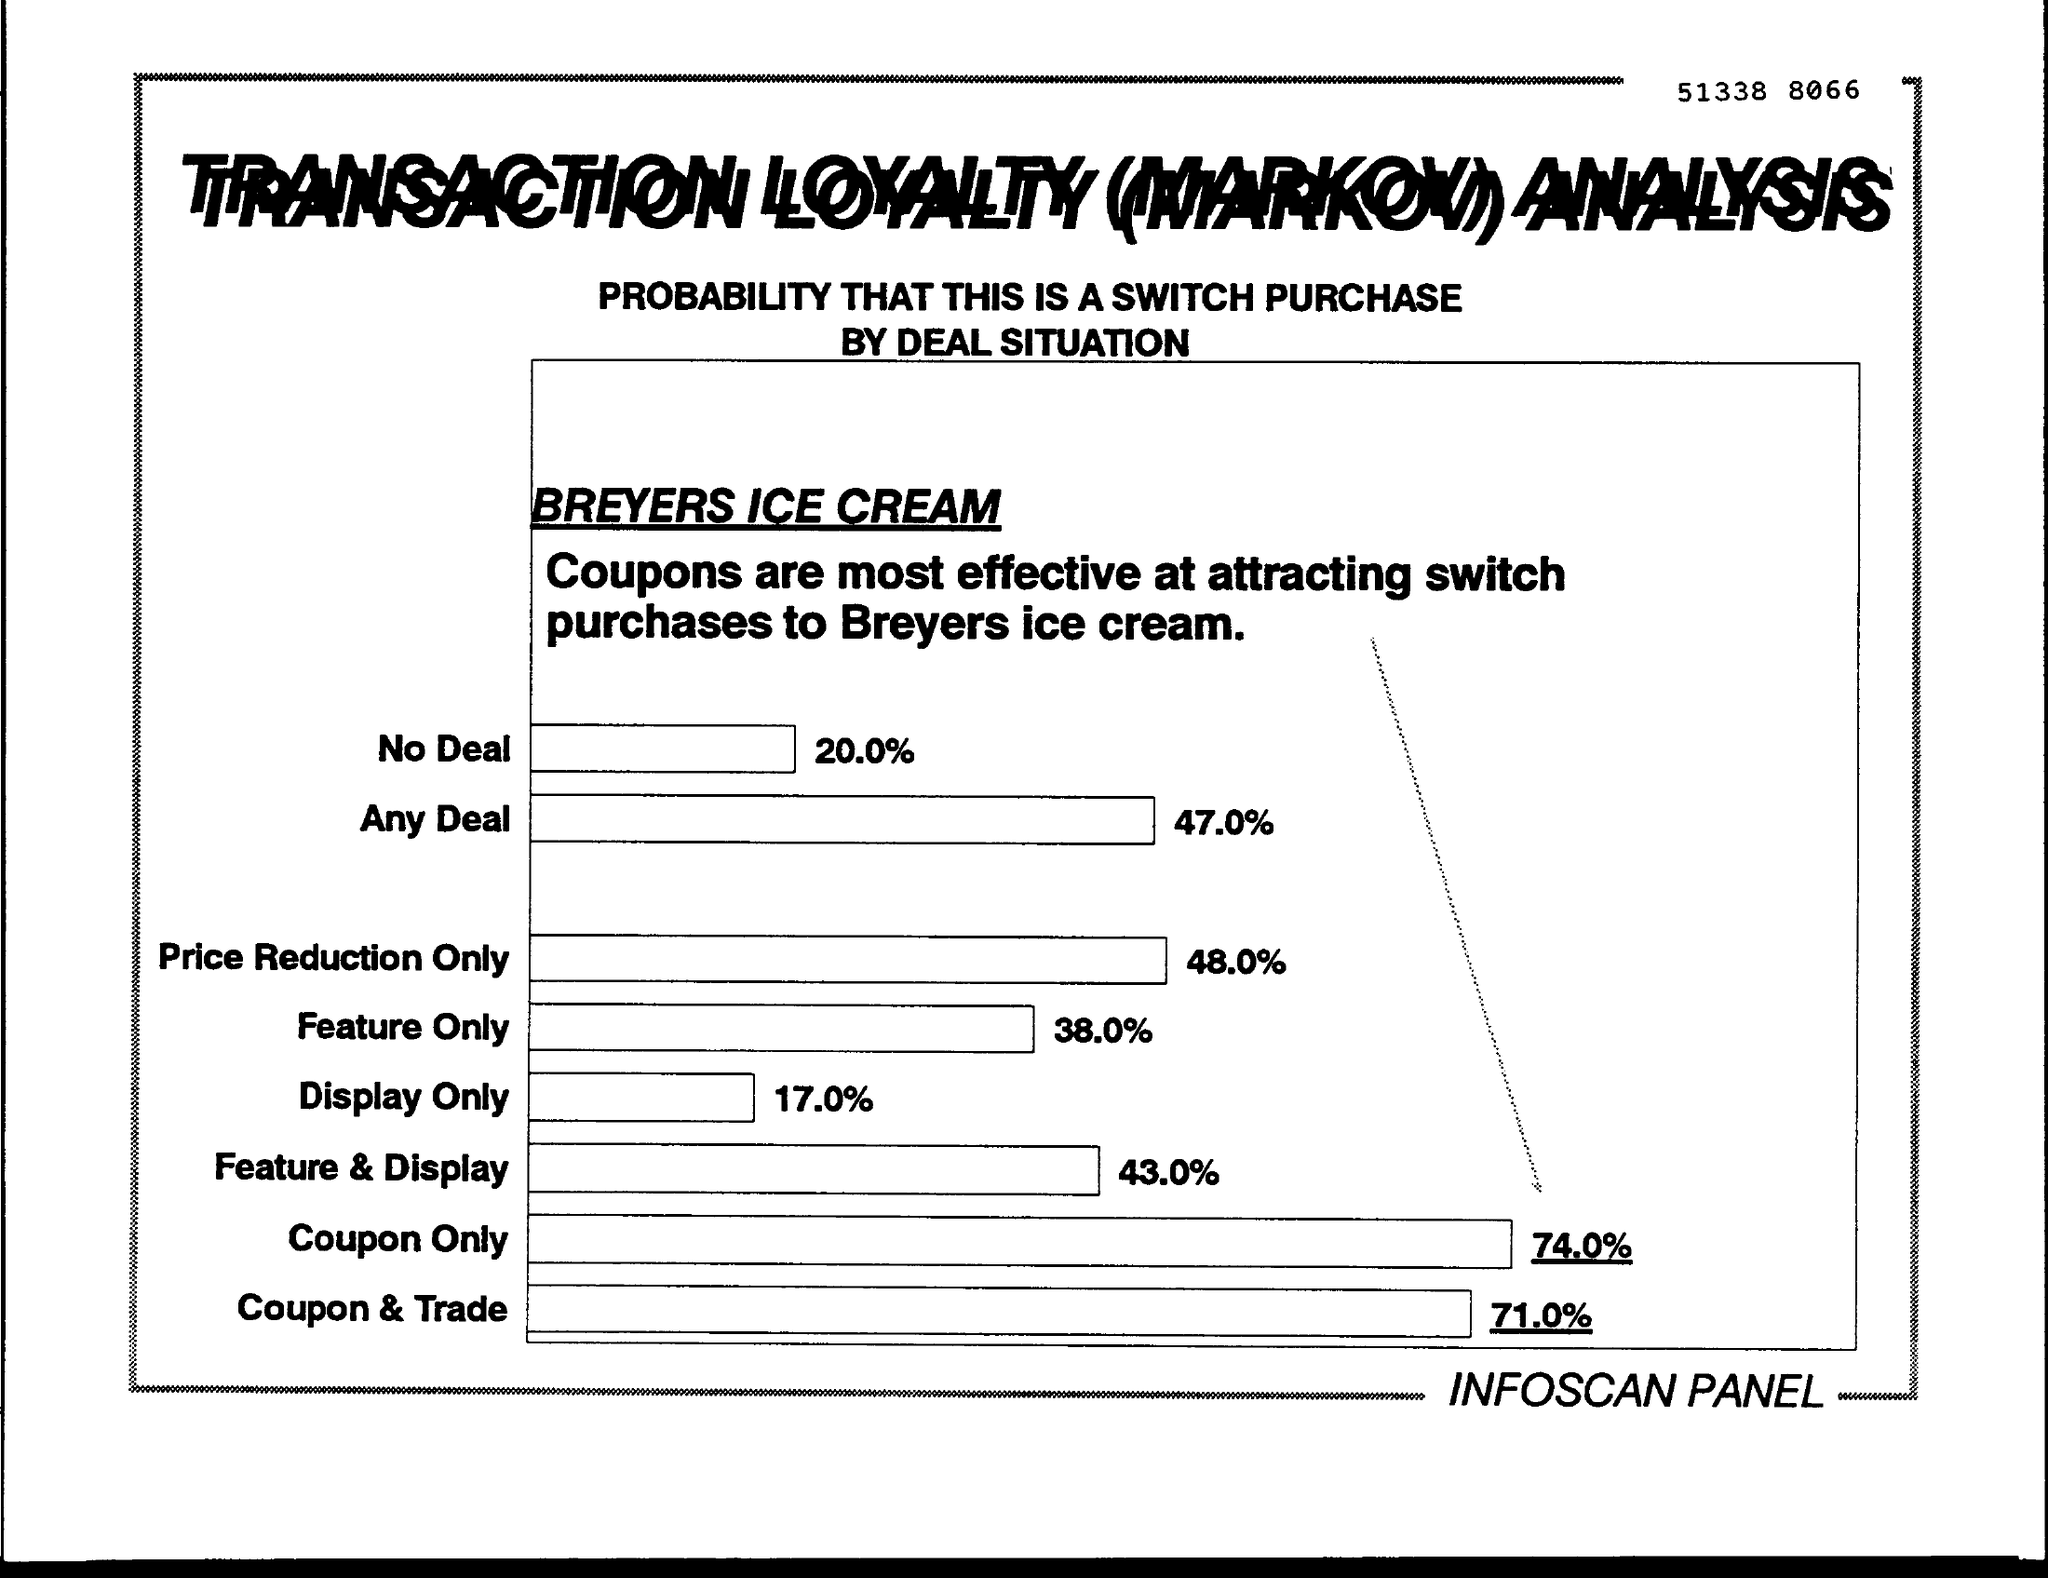What is the % of no deal in a switch purchase in the breyers ice cream ?
Your response must be concise. 20.0 %. What is the % of price reduction only at switch purchases of breyers ice cream ?
Offer a very short reply. 48.0%. What is the % of display only at attracting switch purchases to breyers ice cream ?
Give a very brief answer. 17.0%. What is the % of coupon &trade at attracting switch purchase to breyers ice cream ?
Provide a succinct answer. 71.0%. 